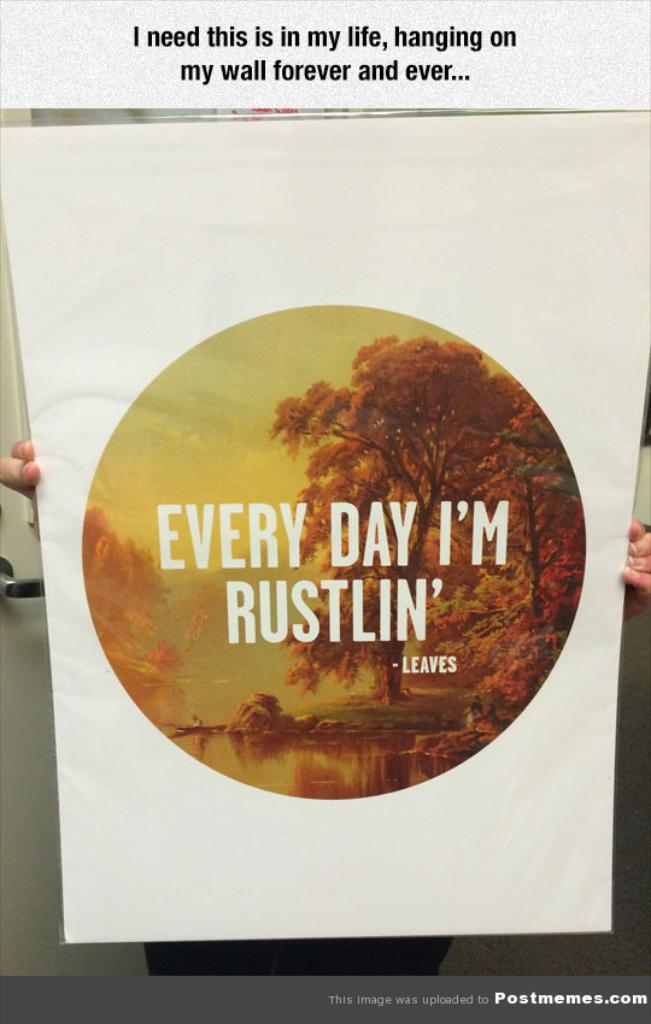<image>
Summarize the visual content of the image. A person holding an Every Day I'm Rustlin' poster. 